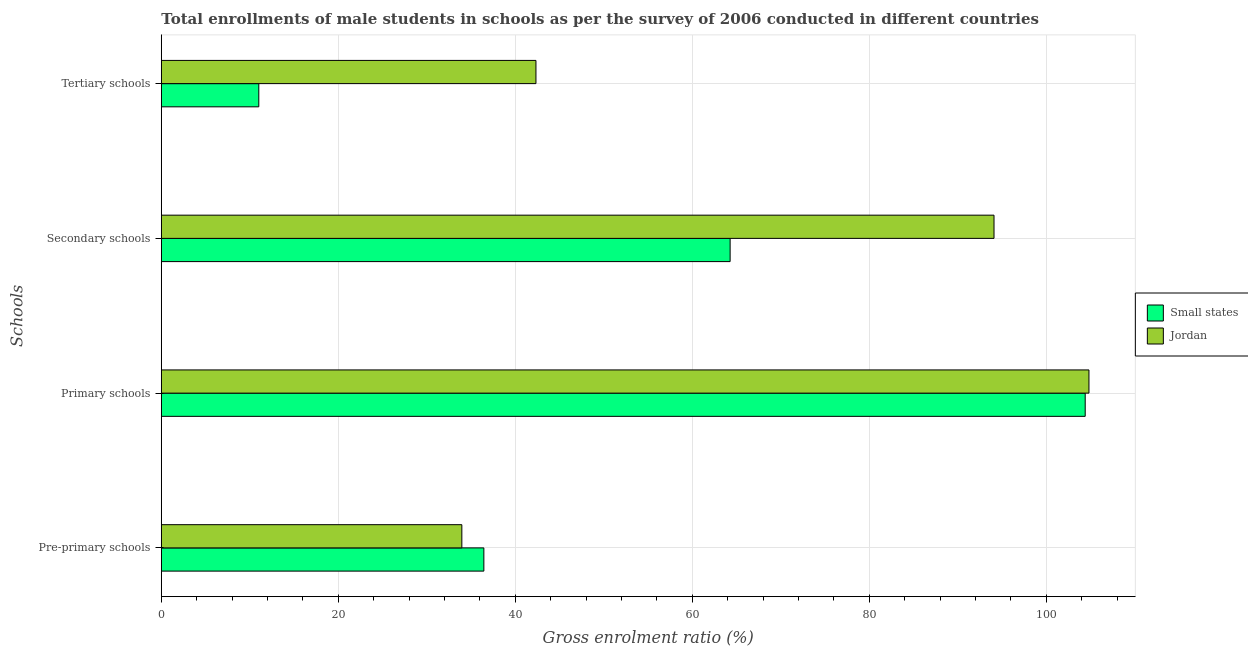How many different coloured bars are there?
Your answer should be compact. 2. Are the number of bars on each tick of the Y-axis equal?
Your response must be concise. Yes. How many bars are there on the 2nd tick from the bottom?
Make the answer very short. 2. What is the label of the 1st group of bars from the top?
Offer a terse response. Tertiary schools. What is the gross enrolment ratio(male) in primary schools in Small states?
Provide a succinct answer. 104.39. Across all countries, what is the maximum gross enrolment ratio(male) in pre-primary schools?
Provide a succinct answer. 36.44. Across all countries, what is the minimum gross enrolment ratio(male) in secondary schools?
Your response must be concise. 64.27. In which country was the gross enrolment ratio(male) in secondary schools maximum?
Provide a short and direct response. Jordan. In which country was the gross enrolment ratio(male) in secondary schools minimum?
Provide a short and direct response. Small states. What is the total gross enrolment ratio(male) in secondary schools in the graph?
Offer a terse response. 158.35. What is the difference between the gross enrolment ratio(male) in tertiary schools in Small states and that in Jordan?
Offer a very short reply. -31.32. What is the difference between the gross enrolment ratio(male) in primary schools in Jordan and the gross enrolment ratio(male) in tertiary schools in Small states?
Offer a terse response. 93.8. What is the average gross enrolment ratio(male) in tertiary schools per country?
Keep it short and to the point. 26.67. What is the difference between the gross enrolment ratio(male) in primary schools and gross enrolment ratio(male) in pre-primary schools in Small states?
Give a very brief answer. 67.94. In how many countries, is the gross enrolment ratio(male) in primary schools greater than 88 %?
Provide a short and direct response. 2. What is the ratio of the gross enrolment ratio(male) in tertiary schools in Small states to that in Jordan?
Give a very brief answer. 0.26. What is the difference between the highest and the second highest gross enrolment ratio(male) in secondary schools?
Offer a very short reply. 29.82. What is the difference between the highest and the lowest gross enrolment ratio(male) in pre-primary schools?
Keep it short and to the point. 2.49. Is the sum of the gross enrolment ratio(male) in secondary schools in Small states and Jordan greater than the maximum gross enrolment ratio(male) in tertiary schools across all countries?
Offer a terse response. Yes. Is it the case that in every country, the sum of the gross enrolment ratio(male) in secondary schools and gross enrolment ratio(male) in pre-primary schools is greater than the sum of gross enrolment ratio(male) in primary schools and gross enrolment ratio(male) in tertiary schools?
Your answer should be very brief. Yes. What does the 1st bar from the top in Pre-primary schools represents?
Keep it short and to the point. Jordan. What does the 2nd bar from the bottom in Primary schools represents?
Your answer should be very brief. Jordan. How many bars are there?
Keep it short and to the point. 8. Are all the bars in the graph horizontal?
Offer a terse response. Yes. How many countries are there in the graph?
Ensure brevity in your answer.  2. What is the difference between two consecutive major ticks on the X-axis?
Offer a terse response. 20. Are the values on the major ticks of X-axis written in scientific E-notation?
Offer a terse response. No. Does the graph contain any zero values?
Offer a very short reply. No. Where does the legend appear in the graph?
Your answer should be very brief. Center right. What is the title of the graph?
Provide a short and direct response. Total enrollments of male students in schools as per the survey of 2006 conducted in different countries. Does "Antigua and Barbuda" appear as one of the legend labels in the graph?
Make the answer very short. No. What is the label or title of the X-axis?
Your answer should be very brief. Gross enrolment ratio (%). What is the label or title of the Y-axis?
Offer a very short reply. Schools. What is the Gross enrolment ratio (%) of Small states in Pre-primary schools?
Provide a short and direct response. 36.44. What is the Gross enrolment ratio (%) of Jordan in Pre-primary schools?
Your answer should be very brief. 33.96. What is the Gross enrolment ratio (%) of Small states in Primary schools?
Your response must be concise. 104.39. What is the Gross enrolment ratio (%) in Jordan in Primary schools?
Your response must be concise. 104.81. What is the Gross enrolment ratio (%) in Small states in Secondary schools?
Make the answer very short. 64.27. What is the Gross enrolment ratio (%) in Jordan in Secondary schools?
Your response must be concise. 94.08. What is the Gross enrolment ratio (%) in Small states in Tertiary schools?
Offer a terse response. 11.01. What is the Gross enrolment ratio (%) of Jordan in Tertiary schools?
Your answer should be very brief. 42.33. Across all Schools, what is the maximum Gross enrolment ratio (%) in Small states?
Offer a very short reply. 104.39. Across all Schools, what is the maximum Gross enrolment ratio (%) in Jordan?
Keep it short and to the point. 104.81. Across all Schools, what is the minimum Gross enrolment ratio (%) of Small states?
Your answer should be very brief. 11.01. Across all Schools, what is the minimum Gross enrolment ratio (%) of Jordan?
Your answer should be very brief. 33.96. What is the total Gross enrolment ratio (%) of Small states in the graph?
Keep it short and to the point. 216.11. What is the total Gross enrolment ratio (%) of Jordan in the graph?
Your response must be concise. 275.18. What is the difference between the Gross enrolment ratio (%) in Small states in Pre-primary schools and that in Primary schools?
Offer a very short reply. -67.94. What is the difference between the Gross enrolment ratio (%) in Jordan in Pre-primary schools and that in Primary schools?
Your answer should be very brief. -70.85. What is the difference between the Gross enrolment ratio (%) in Small states in Pre-primary schools and that in Secondary schools?
Make the answer very short. -27.82. What is the difference between the Gross enrolment ratio (%) of Jordan in Pre-primary schools and that in Secondary schools?
Offer a terse response. -60.13. What is the difference between the Gross enrolment ratio (%) of Small states in Pre-primary schools and that in Tertiary schools?
Offer a terse response. 25.43. What is the difference between the Gross enrolment ratio (%) in Jordan in Pre-primary schools and that in Tertiary schools?
Make the answer very short. -8.37. What is the difference between the Gross enrolment ratio (%) of Small states in Primary schools and that in Secondary schools?
Offer a terse response. 40.12. What is the difference between the Gross enrolment ratio (%) of Jordan in Primary schools and that in Secondary schools?
Your response must be concise. 10.73. What is the difference between the Gross enrolment ratio (%) of Small states in Primary schools and that in Tertiary schools?
Provide a short and direct response. 93.37. What is the difference between the Gross enrolment ratio (%) of Jordan in Primary schools and that in Tertiary schools?
Your response must be concise. 62.48. What is the difference between the Gross enrolment ratio (%) of Small states in Secondary schools and that in Tertiary schools?
Your answer should be compact. 53.25. What is the difference between the Gross enrolment ratio (%) of Jordan in Secondary schools and that in Tertiary schools?
Offer a terse response. 51.76. What is the difference between the Gross enrolment ratio (%) of Small states in Pre-primary schools and the Gross enrolment ratio (%) of Jordan in Primary schools?
Offer a terse response. -68.37. What is the difference between the Gross enrolment ratio (%) in Small states in Pre-primary schools and the Gross enrolment ratio (%) in Jordan in Secondary schools?
Ensure brevity in your answer.  -57.64. What is the difference between the Gross enrolment ratio (%) of Small states in Pre-primary schools and the Gross enrolment ratio (%) of Jordan in Tertiary schools?
Provide a succinct answer. -5.89. What is the difference between the Gross enrolment ratio (%) in Small states in Primary schools and the Gross enrolment ratio (%) in Jordan in Secondary schools?
Keep it short and to the point. 10.3. What is the difference between the Gross enrolment ratio (%) in Small states in Primary schools and the Gross enrolment ratio (%) in Jordan in Tertiary schools?
Offer a very short reply. 62.06. What is the difference between the Gross enrolment ratio (%) of Small states in Secondary schools and the Gross enrolment ratio (%) of Jordan in Tertiary schools?
Offer a terse response. 21.94. What is the average Gross enrolment ratio (%) of Small states per Schools?
Give a very brief answer. 54.03. What is the average Gross enrolment ratio (%) of Jordan per Schools?
Your answer should be very brief. 68.79. What is the difference between the Gross enrolment ratio (%) of Small states and Gross enrolment ratio (%) of Jordan in Pre-primary schools?
Provide a succinct answer. 2.49. What is the difference between the Gross enrolment ratio (%) in Small states and Gross enrolment ratio (%) in Jordan in Primary schools?
Offer a terse response. -0.42. What is the difference between the Gross enrolment ratio (%) in Small states and Gross enrolment ratio (%) in Jordan in Secondary schools?
Make the answer very short. -29.82. What is the difference between the Gross enrolment ratio (%) in Small states and Gross enrolment ratio (%) in Jordan in Tertiary schools?
Provide a succinct answer. -31.32. What is the ratio of the Gross enrolment ratio (%) of Small states in Pre-primary schools to that in Primary schools?
Offer a terse response. 0.35. What is the ratio of the Gross enrolment ratio (%) of Jordan in Pre-primary schools to that in Primary schools?
Your answer should be very brief. 0.32. What is the ratio of the Gross enrolment ratio (%) of Small states in Pre-primary schools to that in Secondary schools?
Your response must be concise. 0.57. What is the ratio of the Gross enrolment ratio (%) of Jordan in Pre-primary schools to that in Secondary schools?
Provide a short and direct response. 0.36. What is the ratio of the Gross enrolment ratio (%) of Small states in Pre-primary schools to that in Tertiary schools?
Offer a very short reply. 3.31. What is the ratio of the Gross enrolment ratio (%) of Jordan in Pre-primary schools to that in Tertiary schools?
Ensure brevity in your answer.  0.8. What is the ratio of the Gross enrolment ratio (%) of Small states in Primary schools to that in Secondary schools?
Your answer should be very brief. 1.62. What is the ratio of the Gross enrolment ratio (%) in Jordan in Primary schools to that in Secondary schools?
Your answer should be very brief. 1.11. What is the ratio of the Gross enrolment ratio (%) of Small states in Primary schools to that in Tertiary schools?
Offer a terse response. 9.48. What is the ratio of the Gross enrolment ratio (%) in Jordan in Primary schools to that in Tertiary schools?
Your answer should be compact. 2.48. What is the ratio of the Gross enrolment ratio (%) of Small states in Secondary schools to that in Tertiary schools?
Your answer should be very brief. 5.84. What is the ratio of the Gross enrolment ratio (%) in Jordan in Secondary schools to that in Tertiary schools?
Your answer should be compact. 2.22. What is the difference between the highest and the second highest Gross enrolment ratio (%) in Small states?
Your response must be concise. 40.12. What is the difference between the highest and the second highest Gross enrolment ratio (%) in Jordan?
Keep it short and to the point. 10.73. What is the difference between the highest and the lowest Gross enrolment ratio (%) of Small states?
Provide a short and direct response. 93.37. What is the difference between the highest and the lowest Gross enrolment ratio (%) of Jordan?
Provide a short and direct response. 70.85. 